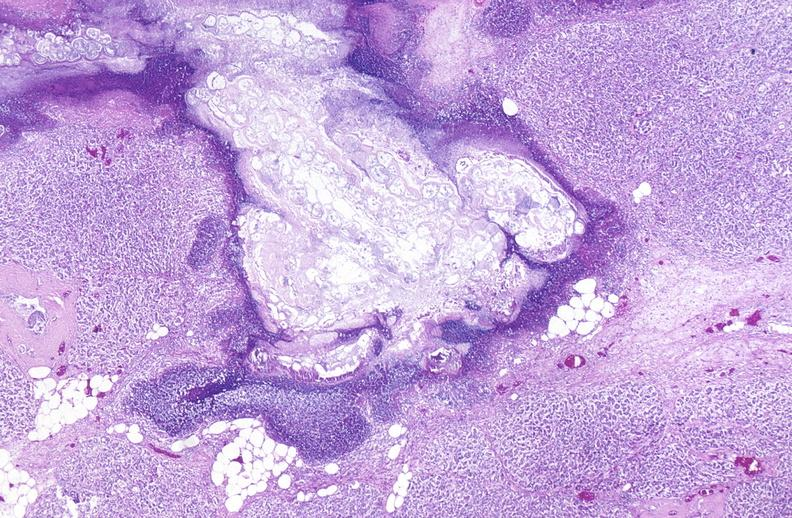what does this image show?
Answer the question using a single word or phrase. Pancreatic fat necrosis 